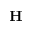Convert formula to latex. <formula><loc_0><loc_0><loc_500><loc_500>H</formula> 